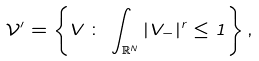<formula> <loc_0><loc_0><loc_500><loc_500>\mathcal { V } ^ { \prime } = \left \{ V \, \colon \, \int _ { \mathbb { R } ^ { N } } | V _ { - } | ^ { r } \leq 1 \right \} ,</formula> 